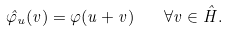<formula> <loc_0><loc_0><loc_500><loc_500>\hat { \varphi } _ { u } ( v ) = \varphi ( u + v ) \quad \forall v \in \hat { H } .</formula> 